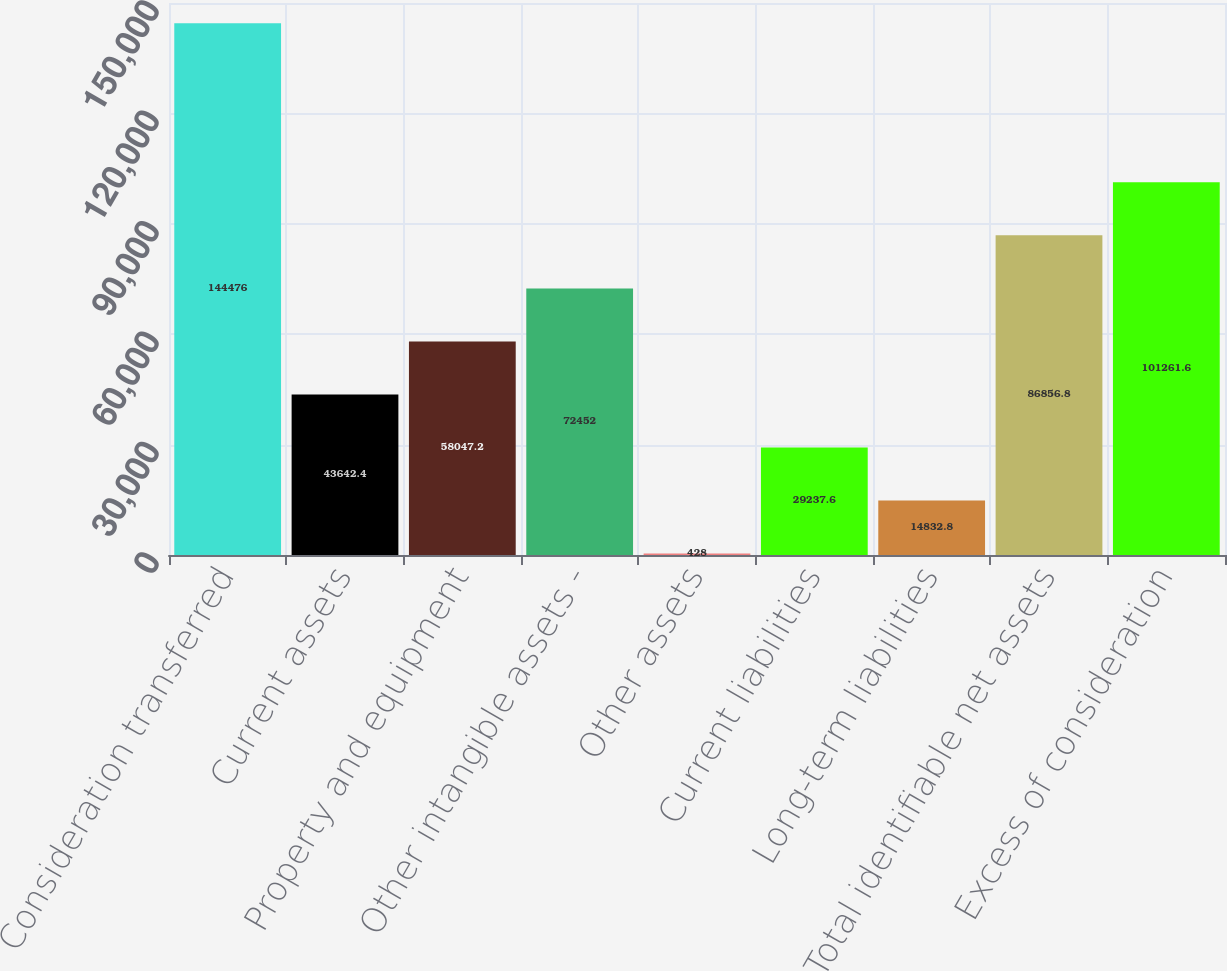<chart> <loc_0><loc_0><loc_500><loc_500><bar_chart><fcel>Consideration transferred<fcel>Current assets<fcel>Property and equipment<fcel>Other intangible assets -<fcel>Other assets<fcel>Current liabilities<fcel>Long-term liabilities<fcel>Total identifiable net assets<fcel>Excess of consideration<nl><fcel>144476<fcel>43642.4<fcel>58047.2<fcel>72452<fcel>428<fcel>29237.6<fcel>14832.8<fcel>86856.8<fcel>101262<nl></chart> 